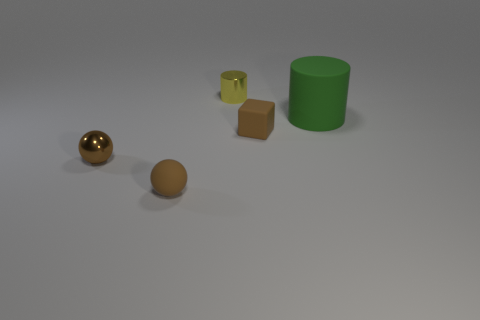Add 4 tiny brown shiny objects. How many objects exist? 9 Subtract all cylinders. How many objects are left? 3 Subtract 0 red balls. How many objects are left? 5 Subtract all tiny blue rubber cylinders. Subtract all brown spheres. How many objects are left? 3 Add 2 cylinders. How many cylinders are left? 4 Add 4 small brown balls. How many small brown balls exist? 6 